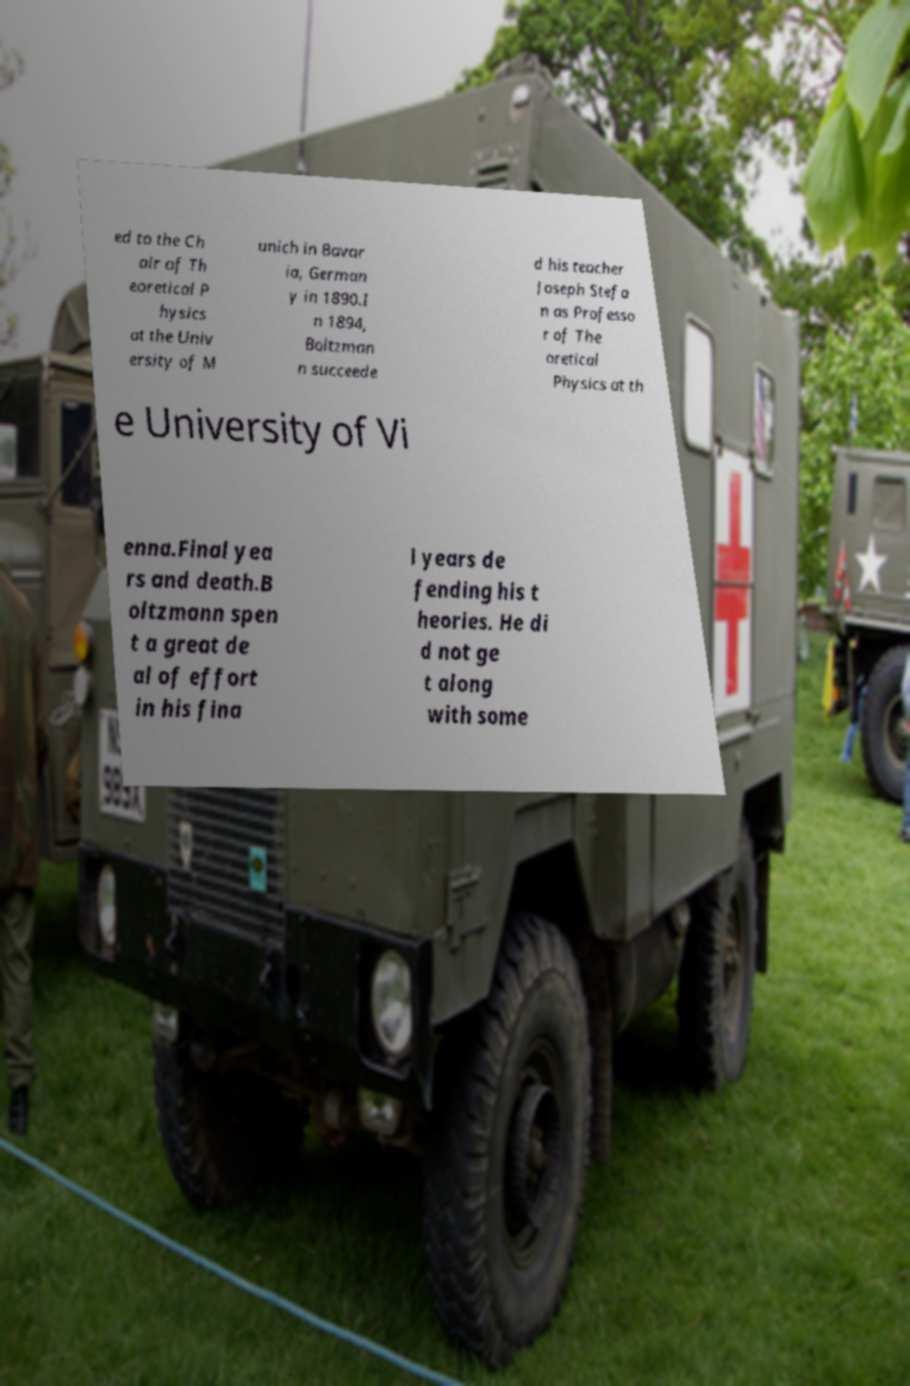Please identify and transcribe the text found in this image. ed to the Ch air of Th eoretical P hysics at the Univ ersity of M unich in Bavar ia, German y in 1890.I n 1894, Boltzman n succeede d his teacher Joseph Stefa n as Professo r of The oretical Physics at th e University of Vi enna.Final yea rs and death.B oltzmann spen t a great de al of effort in his fina l years de fending his t heories. He di d not ge t along with some 